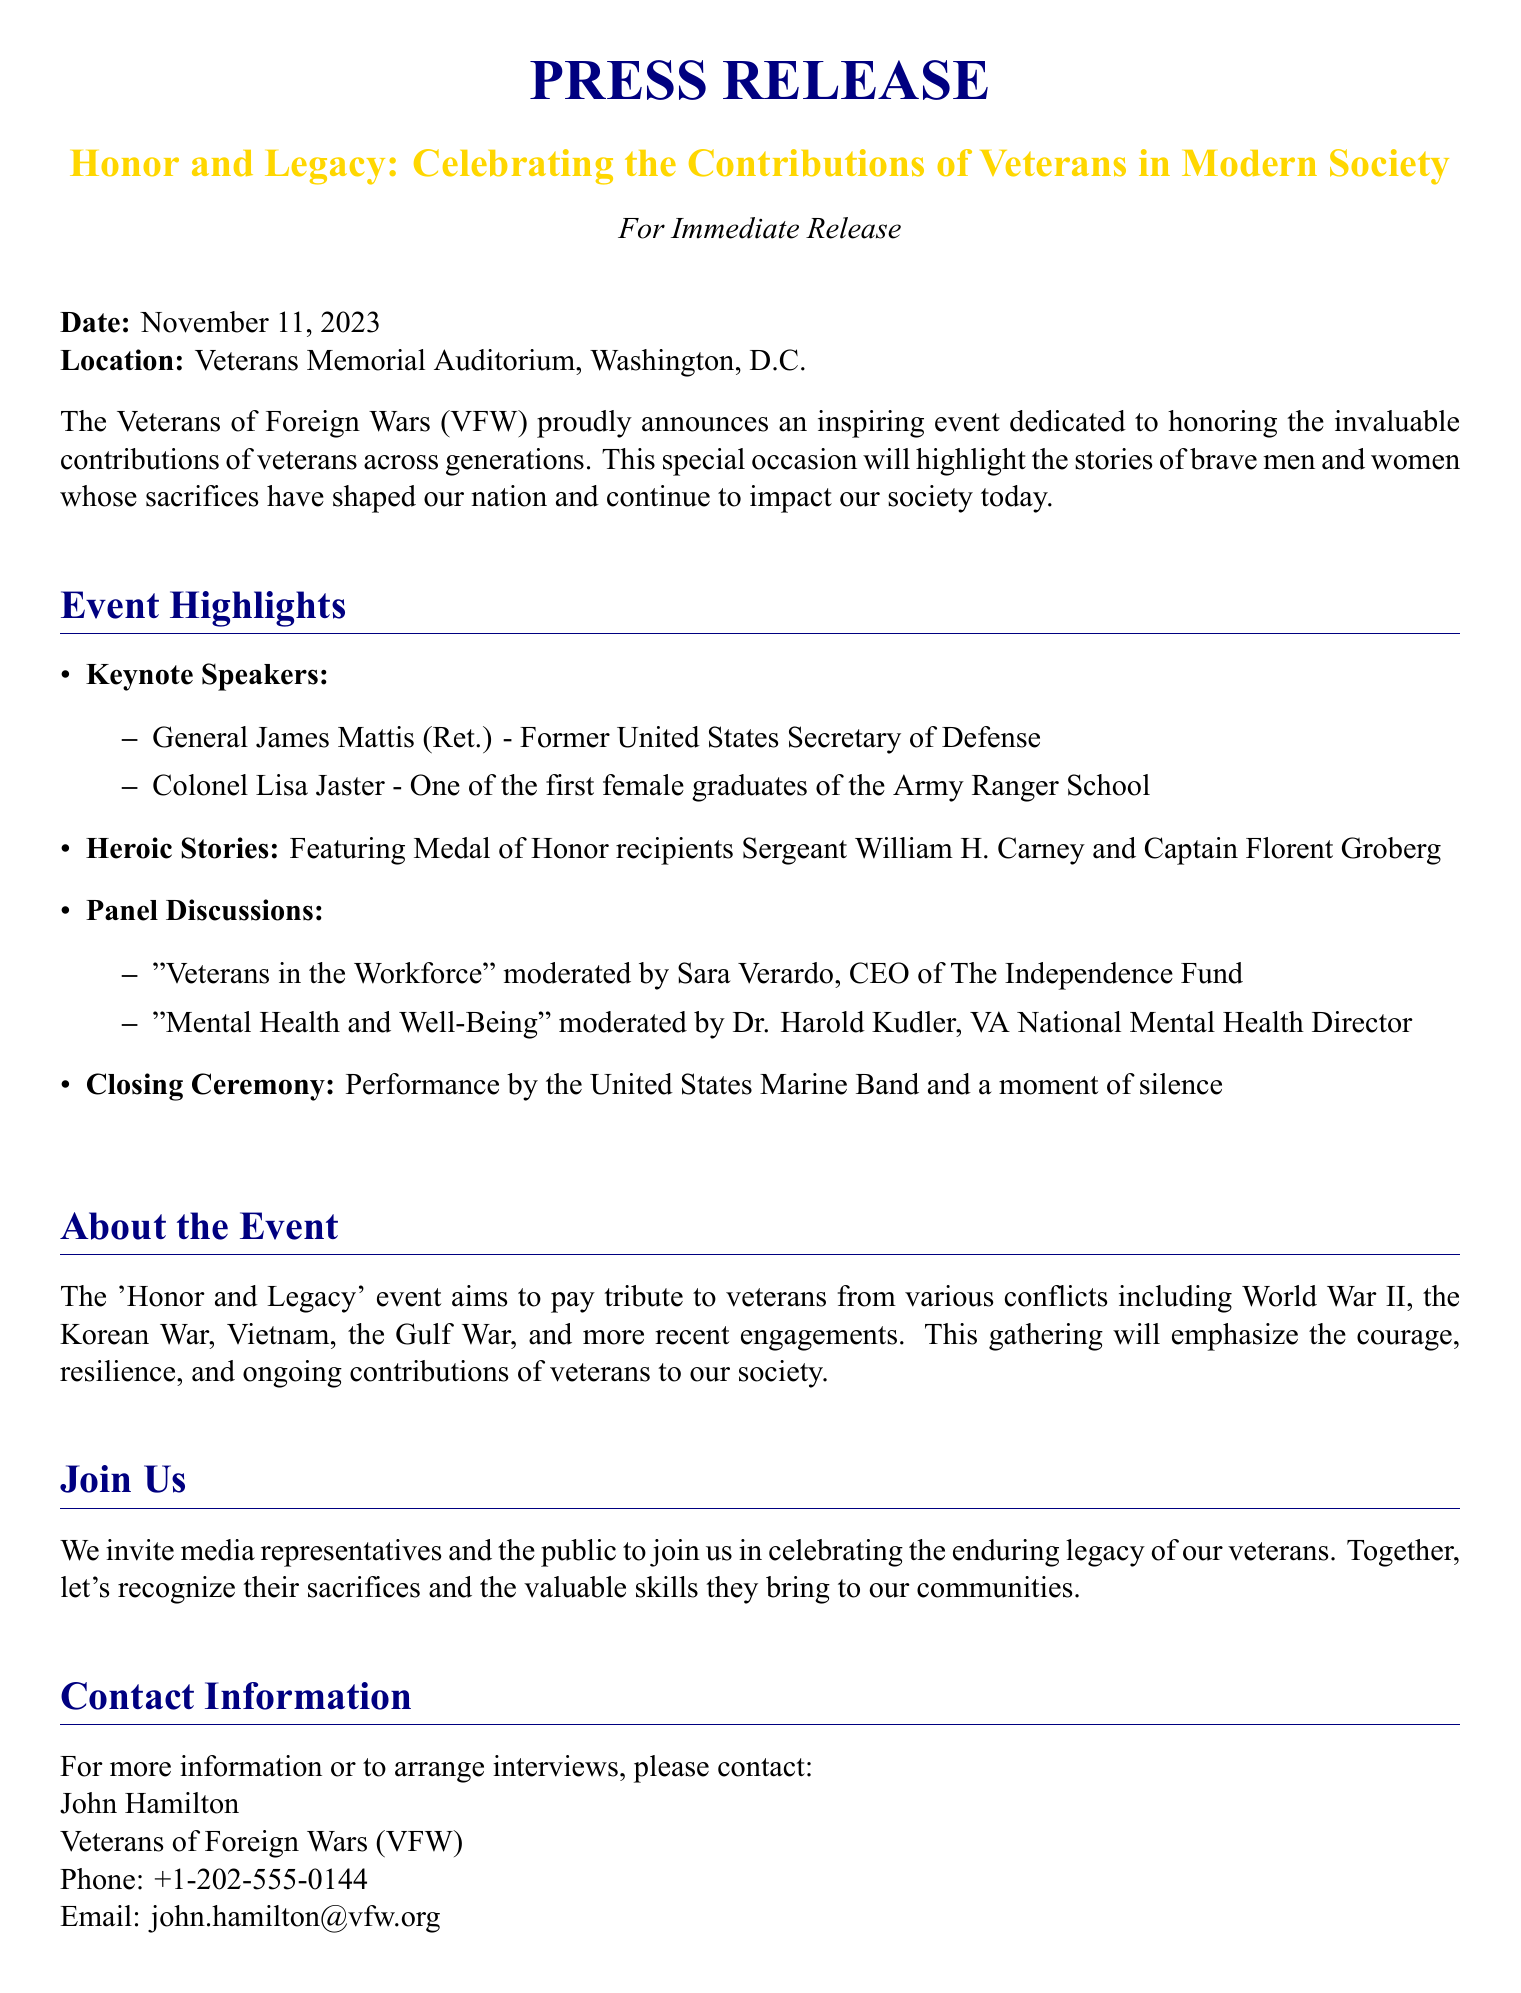What is the date of the event? The date mentioned in the document for the event is November 11, 2023.
Answer: November 11, 2023 Where is the event being held? The location of the event is specified in the document as Veterans Memorial Auditorium, Washington, D.C.
Answer: Veterans Memorial Auditorium, Washington, D.C Who are the keynote speakers? The document lists General James Mattis and Colonel Lisa Jaster as the keynote speakers.
Answer: General James Mattis, Colonel Lisa Jaster What type of stories will be featured? The document mentions that heroic stories will be highlighted, specifically mentioning Medal of Honor recipients.
Answer: Heroic stories What panel discussion topic is moderated by Sara Verardo? According to the document, Sara Verardo moderates the panel discussion on "Veterans in the Workforce."
Answer: Veterans in the Workforce What is the purpose of the 'Honor and Legacy' event? The document states the purpose is to pay tribute to veterans from various conflicts and recognize their contributions.
Answer: To pay tribute to veterans Who should media representatives contact for more information? The contact information provided in the document indicates that John Hamilton is the person to reach out to.
Answer: John Hamilton What will the closing ceremony include? The document describes that the closing ceremony will feature a performance by the United States Marine Band and a moment of silence.
Answer: Performance by the United States Marine Band and a moment of silence 